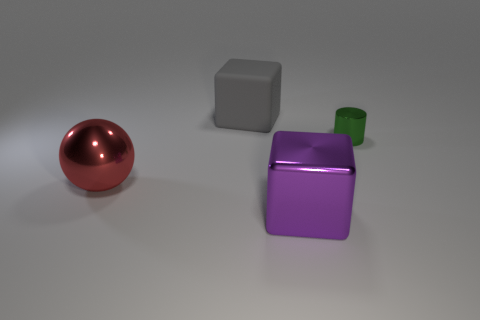How many objects are big things or things in front of the gray matte block?
Keep it short and to the point. 4. Does the metallic thing right of the purple cube have the same size as the big matte object?
Provide a short and direct response. No. What number of other things are the same shape as the big purple metal thing?
Your answer should be compact. 1. How many yellow things are metallic cylinders or large rubber cubes?
Ensure brevity in your answer.  0. There is a object in front of the big red sphere; is its color the same as the cylinder?
Make the answer very short. No. What is the shape of the big red object that is the same material as the tiny green object?
Your answer should be very brief. Sphere. There is a metal object that is to the right of the metal ball and to the left of the tiny green metallic object; what is its color?
Ensure brevity in your answer.  Purple. What size is the metallic thing on the left side of the large metallic thing in front of the large red metal thing?
Provide a short and direct response. Large. Is there a cylinder of the same color as the large rubber cube?
Make the answer very short. No. Are there the same number of metal objects that are behind the tiny green thing and gray things?
Your response must be concise. No. 